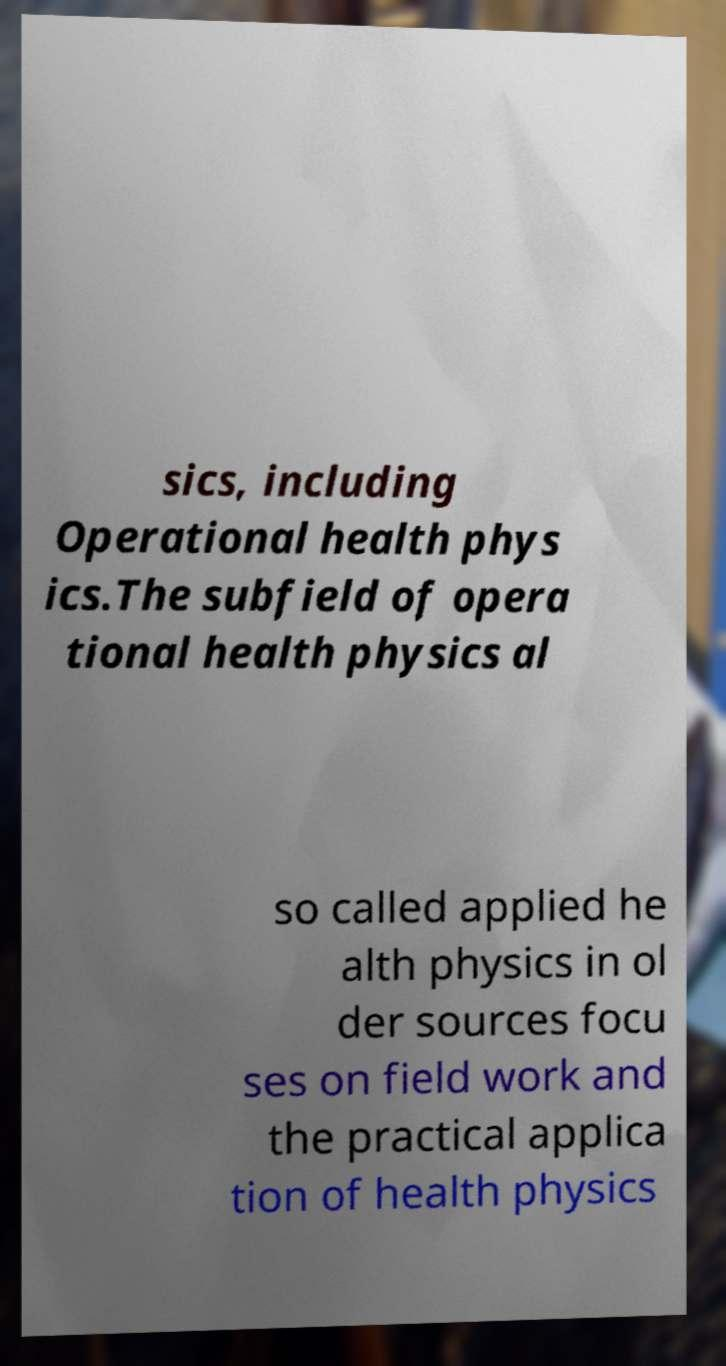Please read and relay the text visible in this image. What does it say? sics, including Operational health phys ics.The subfield of opera tional health physics al so called applied he alth physics in ol der sources focu ses on field work and the practical applica tion of health physics 